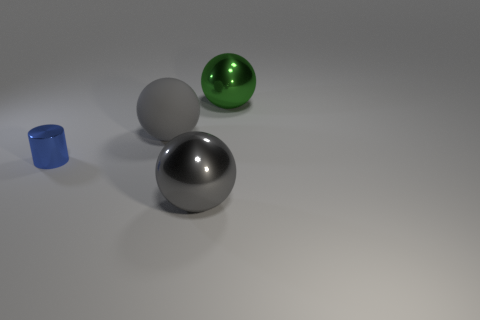Subtract all gray rubber balls. How many balls are left? 2 Subtract all blue blocks. How many gray spheres are left? 2 Subtract all green spheres. How many spheres are left? 2 Subtract all cylinders. How many objects are left? 3 Subtract all green spheres. Subtract all green cylinders. How many spheres are left? 2 Subtract all green balls. Subtract all small cylinders. How many objects are left? 2 Add 1 big green spheres. How many big green spheres are left? 2 Add 1 small shiny objects. How many small shiny objects exist? 2 Add 3 large green objects. How many objects exist? 7 Subtract 0 green blocks. How many objects are left? 4 